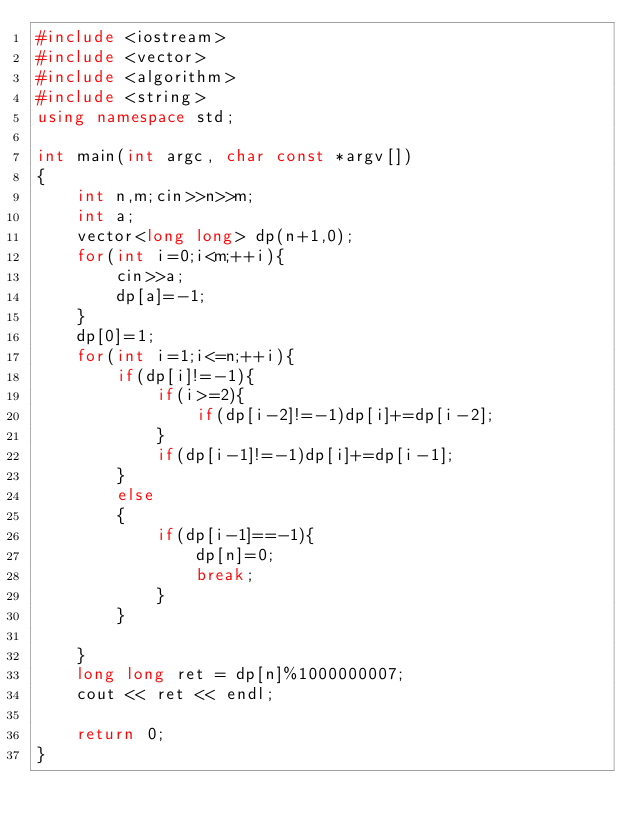<code> <loc_0><loc_0><loc_500><loc_500><_C++_>#include <iostream>
#include <vector>
#include <algorithm>
#include <string>
using namespace std;

int main(int argc, char const *argv[])
{
    int n,m;cin>>n>>m;
    int a;
    vector<long long> dp(n+1,0);
    for(int i=0;i<m;++i){
        cin>>a;
        dp[a]=-1;
    }
    dp[0]=1;
    for(int i=1;i<=n;++i){
        if(dp[i]!=-1){
            if(i>=2){
                if(dp[i-2]!=-1)dp[i]+=dp[i-2];
            }
            if(dp[i-1]!=-1)dp[i]+=dp[i-1];
        }
        else
        {
            if(dp[i-1]==-1){
                dp[n]=0;
                break;
            }
        }
        
    }
    long long ret = dp[n]%1000000007;
    cout << ret << endl;

    return 0;
}
</code> 